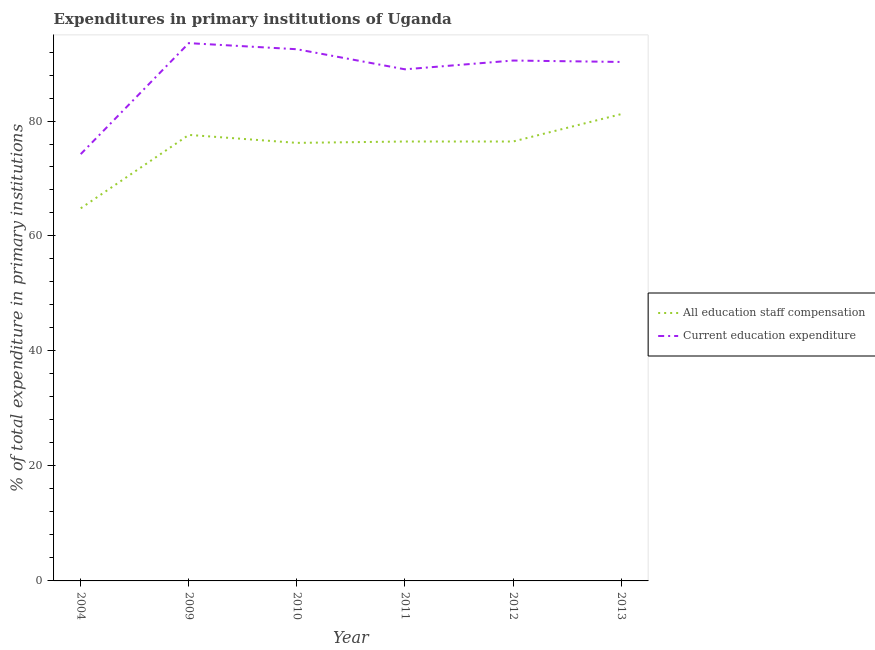Is the number of lines equal to the number of legend labels?
Keep it short and to the point. Yes. What is the expenditure in staff compensation in 2009?
Offer a very short reply. 77.58. Across all years, what is the maximum expenditure in education?
Keep it short and to the point. 93.55. Across all years, what is the minimum expenditure in staff compensation?
Provide a short and direct response. 64.81. In which year was the expenditure in staff compensation maximum?
Your response must be concise. 2013. In which year was the expenditure in staff compensation minimum?
Your answer should be compact. 2004. What is the total expenditure in education in the graph?
Your answer should be very brief. 530.05. What is the difference between the expenditure in staff compensation in 2004 and that in 2012?
Your response must be concise. -11.62. What is the difference between the expenditure in education in 2013 and the expenditure in staff compensation in 2011?
Ensure brevity in your answer.  13.84. What is the average expenditure in education per year?
Ensure brevity in your answer.  88.34. In the year 2010, what is the difference between the expenditure in education and expenditure in staff compensation?
Make the answer very short. 16.29. What is the ratio of the expenditure in staff compensation in 2011 to that in 2013?
Make the answer very short. 0.94. What is the difference between the highest and the second highest expenditure in staff compensation?
Offer a terse response. 3.61. What is the difference between the highest and the lowest expenditure in education?
Provide a succinct answer. 19.3. In how many years, is the expenditure in education greater than the average expenditure in education taken over all years?
Offer a very short reply. 5. Is the sum of the expenditure in staff compensation in 2009 and 2011 greater than the maximum expenditure in education across all years?
Your answer should be compact. Yes. What is the difference between two consecutive major ticks on the Y-axis?
Offer a terse response. 20. Are the values on the major ticks of Y-axis written in scientific E-notation?
Ensure brevity in your answer.  No. Does the graph contain any zero values?
Give a very brief answer. No. Does the graph contain grids?
Ensure brevity in your answer.  No. How many legend labels are there?
Provide a succinct answer. 2. What is the title of the graph?
Give a very brief answer. Expenditures in primary institutions of Uganda. Does "Male entrants" appear as one of the legend labels in the graph?
Make the answer very short. No. What is the label or title of the X-axis?
Ensure brevity in your answer.  Year. What is the label or title of the Y-axis?
Offer a very short reply. % of total expenditure in primary institutions. What is the % of total expenditure in primary institutions of All education staff compensation in 2004?
Your answer should be compact. 64.81. What is the % of total expenditure in primary institutions in Current education expenditure in 2004?
Offer a very short reply. 74.24. What is the % of total expenditure in primary institutions in All education staff compensation in 2009?
Offer a very short reply. 77.58. What is the % of total expenditure in primary institutions of Current education expenditure in 2009?
Provide a succinct answer. 93.55. What is the % of total expenditure in primary institutions in All education staff compensation in 2010?
Ensure brevity in your answer.  76.2. What is the % of total expenditure in primary institutions of Current education expenditure in 2010?
Provide a short and direct response. 92.48. What is the % of total expenditure in primary institutions of All education staff compensation in 2011?
Your answer should be very brief. 76.43. What is the % of total expenditure in primary institutions in Current education expenditure in 2011?
Provide a short and direct response. 88.99. What is the % of total expenditure in primary institutions in All education staff compensation in 2012?
Keep it short and to the point. 76.43. What is the % of total expenditure in primary institutions of Current education expenditure in 2012?
Your response must be concise. 90.52. What is the % of total expenditure in primary institutions in All education staff compensation in 2013?
Ensure brevity in your answer.  81.2. What is the % of total expenditure in primary institutions in Current education expenditure in 2013?
Provide a succinct answer. 90.27. Across all years, what is the maximum % of total expenditure in primary institutions of All education staff compensation?
Ensure brevity in your answer.  81.2. Across all years, what is the maximum % of total expenditure in primary institutions of Current education expenditure?
Your response must be concise. 93.55. Across all years, what is the minimum % of total expenditure in primary institutions in All education staff compensation?
Your answer should be very brief. 64.81. Across all years, what is the minimum % of total expenditure in primary institutions of Current education expenditure?
Your answer should be very brief. 74.24. What is the total % of total expenditure in primary institutions in All education staff compensation in the graph?
Your answer should be very brief. 452.65. What is the total % of total expenditure in primary institutions of Current education expenditure in the graph?
Offer a terse response. 530.05. What is the difference between the % of total expenditure in primary institutions in All education staff compensation in 2004 and that in 2009?
Provide a succinct answer. -12.77. What is the difference between the % of total expenditure in primary institutions of Current education expenditure in 2004 and that in 2009?
Offer a terse response. -19.3. What is the difference between the % of total expenditure in primary institutions in All education staff compensation in 2004 and that in 2010?
Ensure brevity in your answer.  -11.38. What is the difference between the % of total expenditure in primary institutions of Current education expenditure in 2004 and that in 2010?
Provide a short and direct response. -18.24. What is the difference between the % of total expenditure in primary institutions in All education staff compensation in 2004 and that in 2011?
Provide a short and direct response. -11.62. What is the difference between the % of total expenditure in primary institutions in Current education expenditure in 2004 and that in 2011?
Your response must be concise. -14.75. What is the difference between the % of total expenditure in primary institutions of All education staff compensation in 2004 and that in 2012?
Ensure brevity in your answer.  -11.62. What is the difference between the % of total expenditure in primary institutions of Current education expenditure in 2004 and that in 2012?
Keep it short and to the point. -16.28. What is the difference between the % of total expenditure in primary institutions in All education staff compensation in 2004 and that in 2013?
Provide a short and direct response. -16.38. What is the difference between the % of total expenditure in primary institutions of Current education expenditure in 2004 and that in 2013?
Provide a succinct answer. -16.03. What is the difference between the % of total expenditure in primary institutions in All education staff compensation in 2009 and that in 2010?
Make the answer very short. 1.39. What is the difference between the % of total expenditure in primary institutions of Current education expenditure in 2009 and that in 2010?
Provide a succinct answer. 1.06. What is the difference between the % of total expenditure in primary institutions in All education staff compensation in 2009 and that in 2011?
Your answer should be compact. 1.15. What is the difference between the % of total expenditure in primary institutions of Current education expenditure in 2009 and that in 2011?
Your answer should be compact. 4.55. What is the difference between the % of total expenditure in primary institutions of All education staff compensation in 2009 and that in 2012?
Make the answer very short. 1.15. What is the difference between the % of total expenditure in primary institutions of Current education expenditure in 2009 and that in 2012?
Ensure brevity in your answer.  3.03. What is the difference between the % of total expenditure in primary institutions in All education staff compensation in 2009 and that in 2013?
Provide a succinct answer. -3.61. What is the difference between the % of total expenditure in primary institutions of Current education expenditure in 2009 and that in 2013?
Make the answer very short. 3.27. What is the difference between the % of total expenditure in primary institutions of All education staff compensation in 2010 and that in 2011?
Your response must be concise. -0.24. What is the difference between the % of total expenditure in primary institutions in Current education expenditure in 2010 and that in 2011?
Make the answer very short. 3.49. What is the difference between the % of total expenditure in primary institutions in All education staff compensation in 2010 and that in 2012?
Ensure brevity in your answer.  -0.23. What is the difference between the % of total expenditure in primary institutions in Current education expenditure in 2010 and that in 2012?
Your response must be concise. 1.96. What is the difference between the % of total expenditure in primary institutions of All education staff compensation in 2010 and that in 2013?
Give a very brief answer. -5. What is the difference between the % of total expenditure in primary institutions in Current education expenditure in 2010 and that in 2013?
Keep it short and to the point. 2.21. What is the difference between the % of total expenditure in primary institutions in All education staff compensation in 2011 and that in 2012?
Give a very brief answer. 0. What is the difference between the % of total expenditure in primary institutions of Current education expenditure in 2011 and that in 2012?
Your response must be concise. -1.53. What is the difference between the % of total expenditure in primary institutions of All education staff compensation in 2011 and that in 2013?
Offer a terse response. -4.76. What is the difference between the % of total expenditure in primary institutions of Current education expenditure in 2011 and that in 2013?
Make the answer very short. -1.28. What is the difference between the % of total expenditure in primary institutions in All education staff compensation in 2012 and that in 2013?
Your response must be concise. -4.76. What is the difference between the % of total expenditure in primary institutions in Current education expenditure in 2012 and that in 2013?
Your response must be concise. 0.24. What is the difference between the % of total expenditure in primary institutions of All education staff compensation in 2004 and the % of total expenditure in primary institutions of Current education expenditure in 2009?
Keep it short and to the point. -28.73. What is the difference between the % of total expenditure in primary institutions in All education staff compensation in 2004 and the % of total expenditure in primary institutions in Current education expenditure in 2010?
Provide a succinct answer. -27.67. What is the difference between the % of total expenditure in primary institutions in All education staff compensation in 2004 and the % of total expenditure in primary institutions in Current education expenditure in 2011?
Ensure brevity in your answer.  -24.18. What is the difference between the % of total expenditure in primary institutions of All education staff compensation in 2004 and the % of total expenditure in primary institutions of Current education expenditure in 2012?
Offer a very short reply. -25.71. What is the difference between the % of total expenditure in primary institutions of All education staff compensation in 2004 and the % of total expenditure in primary institutions of Current education expenditure in 2013?
Your answer should be compact. -25.46. What is the difference between the % of total expenditure in primary institutions in All education staff compensation in 2009 and the % of total expenditure in primary institutions in Current education expenditure in 2010?
Offer a terse response. -14.9. What is the difference between the % of total expenditure in primary institutions in All education staff compensation in 2009 and the % of total expenditure in primary institutions in Current education expenditure in 2011?
Ensure brevity in your answer.  -11.41. What is the difference between the % of total expenditure in primary institutions in All education staff compensation in 2009 and the % of total expenditure in primary institutions in Current education expenditure in 2012?
Provide a short and direct response. -12.93. What is the difference between the % of total expenditure in primary institutions in All education staff compensation in 2009 and the % of total expenditure in primary institutions in Current education expenditure in 2013?
Keep it short and to the point. -12.69. What is the difference between the % of total expenditure in primary institutions of All education staff compensation in 2010 and the % of total expenditure in primary institutions of Current education expenditure in 2011?
Your answer should be compact. -12.79. What is the difference between the % of total expenditure in primary institutions of All education staff compensation in 2010 and the % of total expenditure in primary institutions of Current education expenditure in 2012?
Keep it short and to the point. -14.32. What is the difference between the % of total expenditure in primary institutions of All education staff compensation in 2010 and the % of total expenditure in primary institutions of Current education expenditure in 2013?
Ensure brevity in your answer.  -14.08. What is the difference between the % of total expenditure in primary institutions in All education staff compensation in 2011 and the % of total expenditure in primary institutions in Current education expenditure in 2012?
Provide a succinct answer. -14.09. What is the difference between the % of total expenditure in primary institutions of All education staff compensation in 2011 and the % of total expenditure in primary institutions of Current education expenditure in 2013?
Offer a terse response. -13.84. What is the difference between the % of total expenditure in primary institutions in All education staff compensation in 2012 and the % of total expenditure in primary institutions in Current education expenditure in 2013?
Provide a short and direct response. -13.84. What is the average % of total expenditure in primary institutions of All education staff compensation per year?
Your response must be concise. 75.44. What is the average % of total expenditure in primary institutions of Current education expenditure per year?
Your answer should be very brief. 88.34. In the year 2004, what is the difference between the % of total expenditure in primary institutions in All education staff compensation and % of total expenditure in primary institutions in Current education expenditure?
Give a very brief answer. -9.43. In the year 2009, what is the difference between the % of total expenditure in primary institutions in All education staff compensation and % of total expenditure in primary institutions in Current education expenditure?
Provide a succinct answer. -15.96. In the year 2010, what is the difference between the % of total expenditure in primary institutions in All education staff compensation and % of total expenditure in primary institutions in Current education expenditure?
Offer a very short reply. -16.29. In the year 2011, what is the difference between the % of total expenditure in primary institutions of All education staff compensation and % of total expenditure in primary institutions of Current education expenditure?
Keep it short and to the point. -12.56. In the year 2012, what is the difference between the % of total expenditure in primary institutions in All education staff compensation and % of total expenditure in primary institutions in Current education expenditure?
Your response must be concise. -14.09. In the year 2013, what is the difference between the % of total expenditure in primary institutions in All education staff compensation and % of total expenditure in primary institutions in Current education expenditure?
Ensure brevity in your answer.  -9.08. What is the ratio of the % of total expenditure in primary institutions of All education staff compensation in 2004 to that in 2009?
Make the answer very short. 0.84. What is the ratio of the % of total expenditure in primary institutions in Current education expenditure in 2004 to that in 2009?
Provide a short and direct response. 0.79. What is the ratio of the % of total expenditure in primary institutions in All education staff compensation in 2004 to that in 2010?
Offer a very short reply. 0.85. What is the ratio of the % of total expenditure in primary institutions in Current education expenditure in 2004 to that in 2010?
Offer a terse response. 0.8. What is the ratio of the % of total expenditure in primary institutions in All education staff compensation in 2004 to that in 2011?
Keep it short and to the point. 0.85. What is the ratio of the % of total expenditure in primary institutions in Current education expenditure in 2004 to that in 2011?
Your answer should be very brief. 0.83. What is the ratio of the % of total expenditure in primary institutions in All education staff compensation in 2004 to that in 2012?
Make the answer very short. 0.85. What is the ratio of the % of total expenditure in primary institutions of Current education expenditure in 2004 to that in 2012?
Give a very brief answer. 0.82. What is the ratio of the % of total expenditure in primary institutions of All education staff compensation in 2004 to that in 2013?
Provide a short and direct response. 0.8. What is the ratio of the % of total expenditure in primary institutions in Current education expenditure in 2004 to that in 2013?
Make the answer very short. 0.82. What is the ratio of the % of total expenditure in primary institutions of All education staff compensation in 2009 to that in 2010?
Ensure brevity in your answer.  1.02. What is the ratio of the % of total expenditure in primary institutions of Current education expenditure in 2009 to that in 2010?
Make the answer very short. 1.01. What is the ratio of the % of total expenditure in primary institutions of All education staff compensation in 2009 to that in 2011?
Ensure brevity in your answer.  1.02. What is the ratio of the % of total expenditure in primary institutions in Current education expenditure in 2009 to that in 2011?
Offer a terse response. 1.05. What is the ratio of the % of total expenditure in primary institutions in All education staff compensation in 2009 to that in 2012?
Ensure brevity in your answer.  1.02. What is the ratio of the % of total expenditure in primary institutions in Current education expenditure in 2009 to that in 2012?
Your response must be concise. 1.03. What is the ratio of the % of total expenditure in primary institutions in All education staff compensation in 2009 to that in 2013?
Give a very brief answer. 0.96. What is the ratio of the % of total expenditure in primary institutions of Current education expenditure in 2009 to that in 2013?
Provide a succinct answer. 1.04. What is the ratio of the % of total expenditure in primary institutions of Current education expenditure in 2010 to that in 2011?
Provide a succinct answer. 1.04. What is the ratio of the % of total expenditure in primary institutions in Current education expenditure in 2010 to that in 2012?
Your answer should be compact. 1.02. What is the ratio of the % of total expenditure in primary institutions of All education staff compensation in 2010 to that in 2013?
Offer a very short reply. 0.94. What is the ratio of the % of total expenditure in primary institutions in Current education expenditure in 2010 to that in 2013?
Your answer should be compact. 1.02. What is the ratio of the % of total expenditure in primary institutions in All education staff compensation in 2011 to that in 2012?
Your response must be concise. 1. What is the ratio of the % of total expenditure in primary institutions of Current education expenditure in 2011 to that in 2012?
Your answer should be compact. 0.98. What is the ratio of the % of total expenditure in primary institutions of All education staff compensation in 2011 to that in 2013?
Offer a very short reply. 0.94. What is the ratio of the % of total expenditure in primary institutions of Current education expenditure in 2011 to that in 2013?
Your answer should be compact. 0.99. What is the ratio of the % of total expenditure in primary institutions in All education staff compensation in 2012 to that in 2013?
Give a very brief answer. 0.94. What is the difference between the highest and the second highest % of total expenditure in primary institutions of All education staff compensation?
Provide a succinct answer. 3.61. What is the difference between the highest and the second highest % of total expenditure in primary institutions in Current education expenditure?
Offer a very short reply. 1.06. What is the difference between the highest and the lowest % of total expenditure in primary institutions in All education staff compensation?
Make the answer very short. 16.38. What is the difference between the highest and the lowest % of total expenditure in primary institutions of Current education expenditure?
Your answer should be very brief. 19.3. 